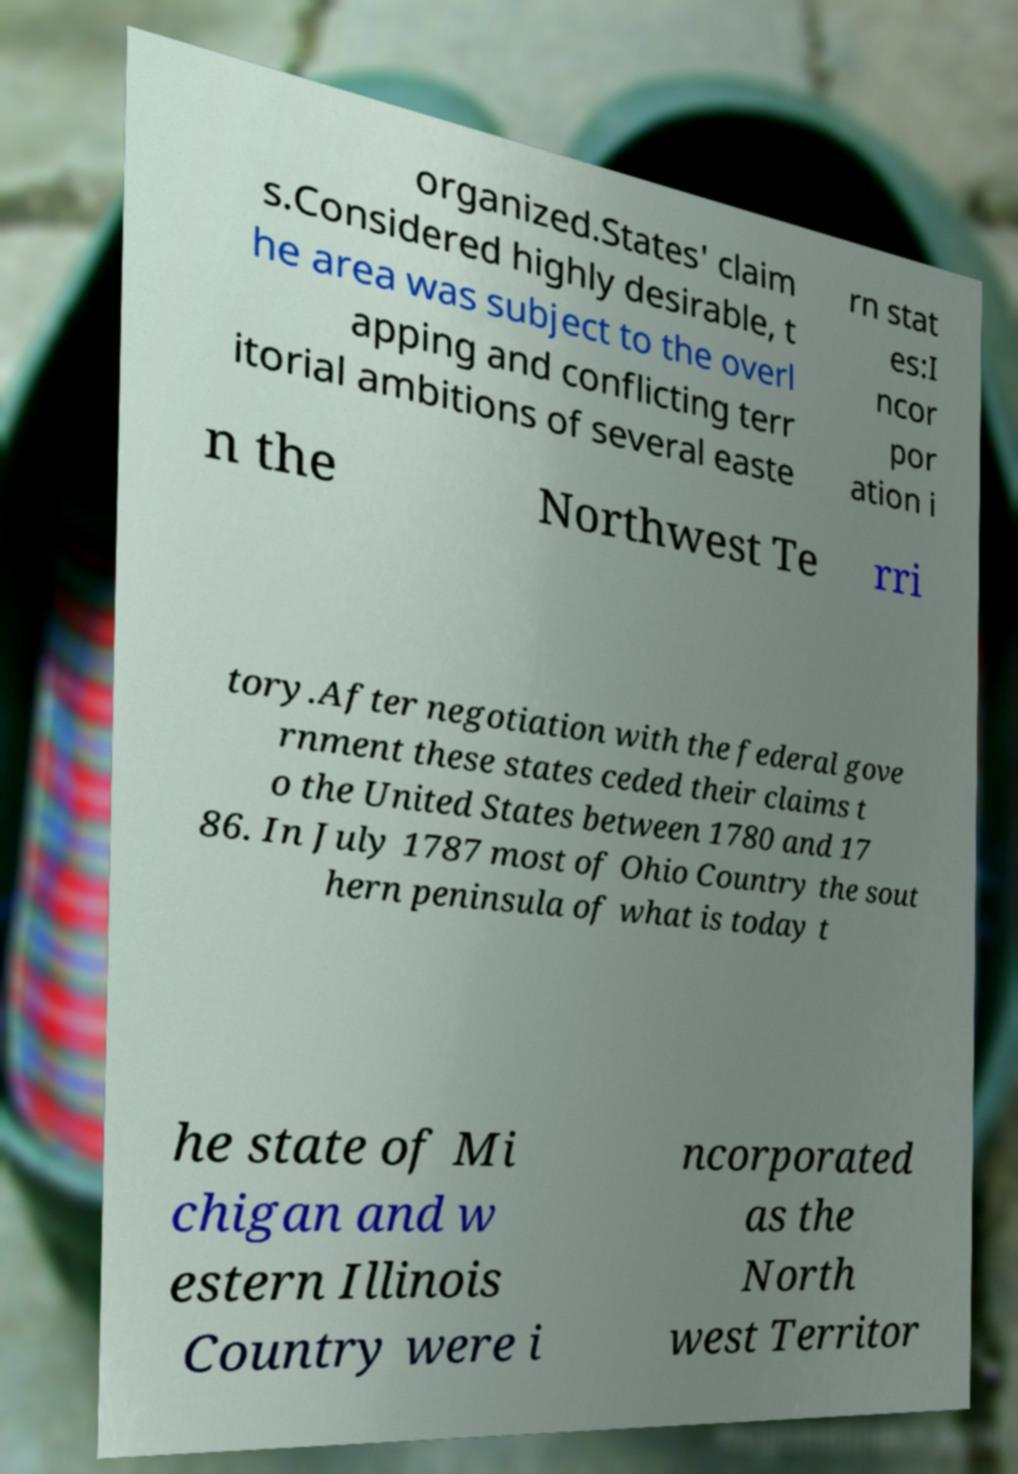Can you read and provide the text displayed in the image?This photo seems to have some interesting text. Can you extract and type it out for me? organized.States' claim s.Considered highly desirable, t he area was subject to the overl apping and conflicting terr itorial ambitions of several easte rn stat es:I ncor por ation i n the Northwest Te rri tory.After negotiation with the federal gove rnment these states ceded their claims t o the United States between 1780 and 17 86. In July 1787 most of Ohio Country the sout hern peninsula of what is today t he state of Mi chigan and w estern Illinois Country were i ncorporated as the North west Territor 